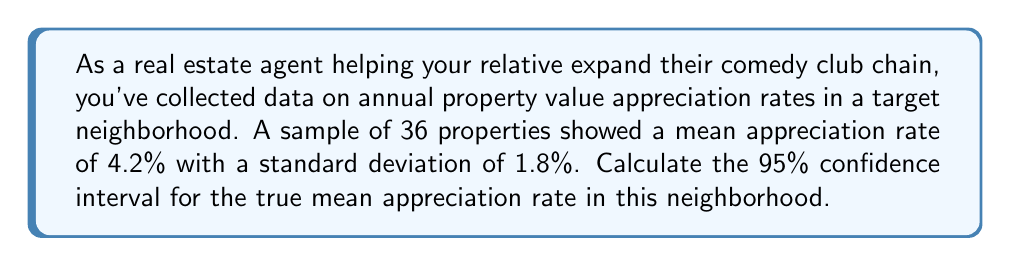Give your solution to this math problem. Let's approach this step-by-step:

1) We are given:
   - Sample size, $n = 36$
   - Sample mean, $\bar{x} = 4.2\%$
   - Sample standard deviation, $s = 1.8\%$
   - Confidence level = 95%

2) For a 95% confidence interval, we use a $z$-score of 1.96.

3) The formula for the confidence interval is:

   $$\bar{x} \pm z \cdot \frac{s}{\sqrt{n}}$$

4) Let's calculate the margin of error:

   $$\text{Margin of Error} = z \cdot \frac{s}{\sqrt{n}} = 1.96 \cdot \frac{1.8}{\sqrt{36}} = 1.96 \cdot \frac{1.8}{6} = 0.588$$

5) Now, we can calculate the lower and upper bounds of the confidence interval:

   Lower bound: $4.2\% - 0.588\% = 3.612\%$
   Upper bound: $4.2\% + 0.588\% = 4.788\%$

6) Therefore, we are 95% confident that the true mean appreciation rate in this neighborhood is between 3.612% and 4.788%.
Answer: (3.612%, 4.788%) 